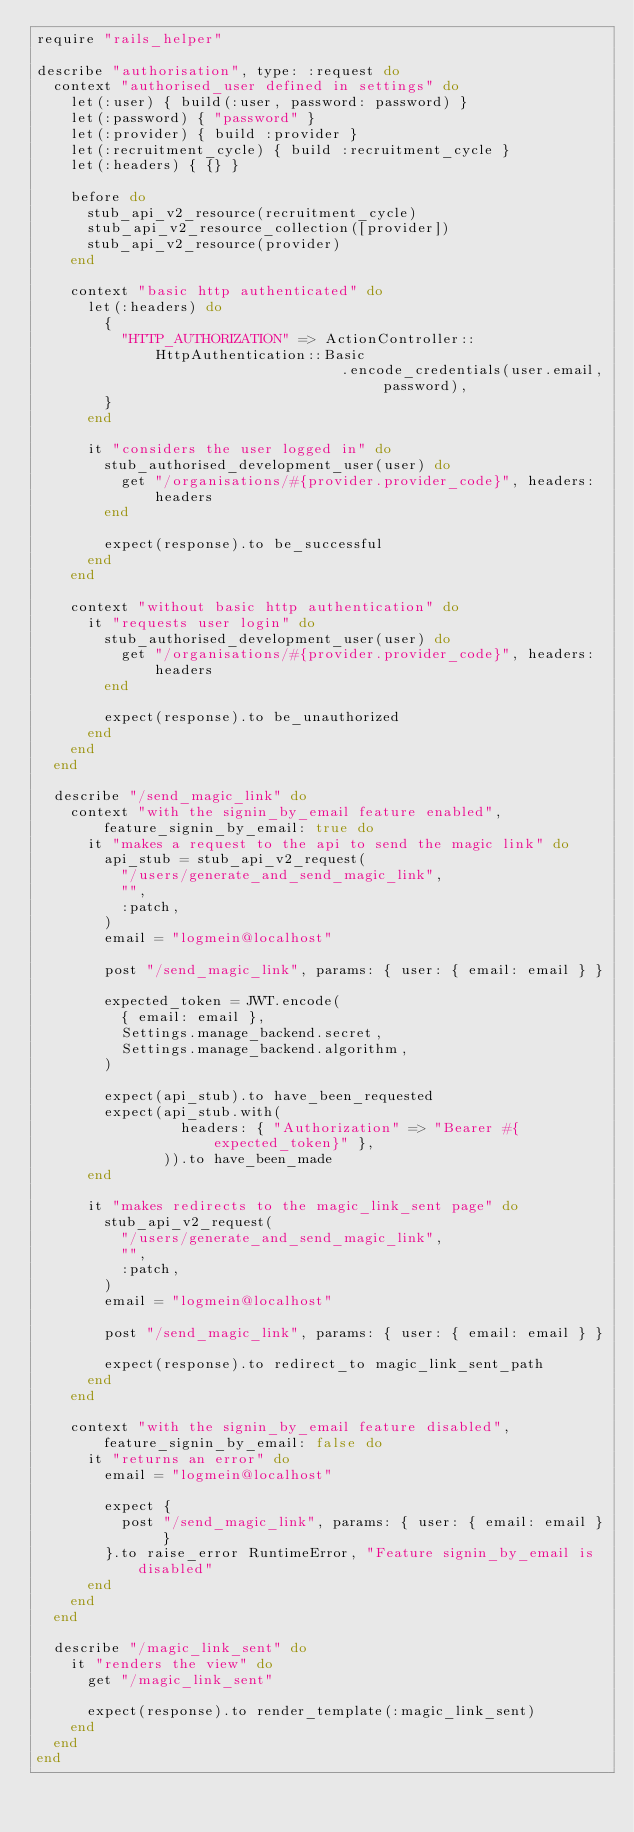Convert code to text. <code><loc_0><loc_0><loc_500><loc_500><_Ruby_>require "rails_helper"

describe "authorisation", type: :request do
  context "authorised_user defined in settings" do
    let(:user) { build(:user, password: password) }
    let(:password) { "password" }
    let(:provider) { build :provider }
    let(:recruitment_cycle) { build :recruitment_cycle }
    let(:headers) { {} }

    before do
      stub_api_v2_resource(recruitment_cycle)
      stub_api_v2_resource_collection([provider])
      stub_api_v2_resource(provider)
    end

    context "basic http authenticated" do
      let(:headers) do
        {
          "HTTP_AUTHORIZATION" => ActionController::HttpAuthentication::Basic
                                    .encode_credentials(user.email, password),
        }
      end

      it "considers the user logged in" do
        stub_authorised_development_user(user) do
          get "/organisations/#{provider.provider_code}", headers: headers
        end

        expect(response).to be_successful
      end
    end

    context "without basic http authentication" do
      it "requests user login" do
        stub_authorised_development_user(user) do
          get "/organisations/#{provider.provider_code}", headers: headers
        end

        expect(response).to be_unauthorized
      end
    end
  end

  describe "/send_magic_link" do
    context "with the signin_by_email feature enabled", feature_signin_by_email: true do
      it "makes a request to the api to send the magic link" do
        api_stub = stub_api_v2_request(
          "/users/generate_and_send_magic_link",
          "",
          :patch,
        )
        email = "logmein@localhost"

        post "/send_magic_link", params: { user: { email: email } }

        expected_token = JWT.encode(
          { email: email },
          Settings.manage_backend.secret,
          Settings.manage_backend.algorithm,
        )

        expect(api_stub).to have_been_requested
        expect(api_stub.with(
                 headers: { "Authorization" => "Bearer #{expected_token}" },
               )).to have_been_made
      end

      it "makes redirects to the magic_link_sent page" do
        stub_api_v2_request(
          "/users/generate_and_send_magic_link",
          "",
          :patch,
        )
        email = "logmein@localhost"

        post "/send_magic_link", params: { user: { email: email } }

        expect(response).to redirect_to magic_link_sent_path
      end
    end

    context "with the signin_by_email feature disabled", feature_signin_by_email: false do
      it "returns an error" do
        email = "logmein@localhost"

        expect {
          post "/send_magic_link", params: { user: { email: email } }
        }.to raise_error RuntimeError, "Feature signin_by_email is disabled"
      end
    end
  end

  describe "/magic_link_sent" do
    it "renders the view" do
      get "/magic_link_sent"

      expect(response).to render_template(:magic_link_sent)
    end
  end
end
</code> 